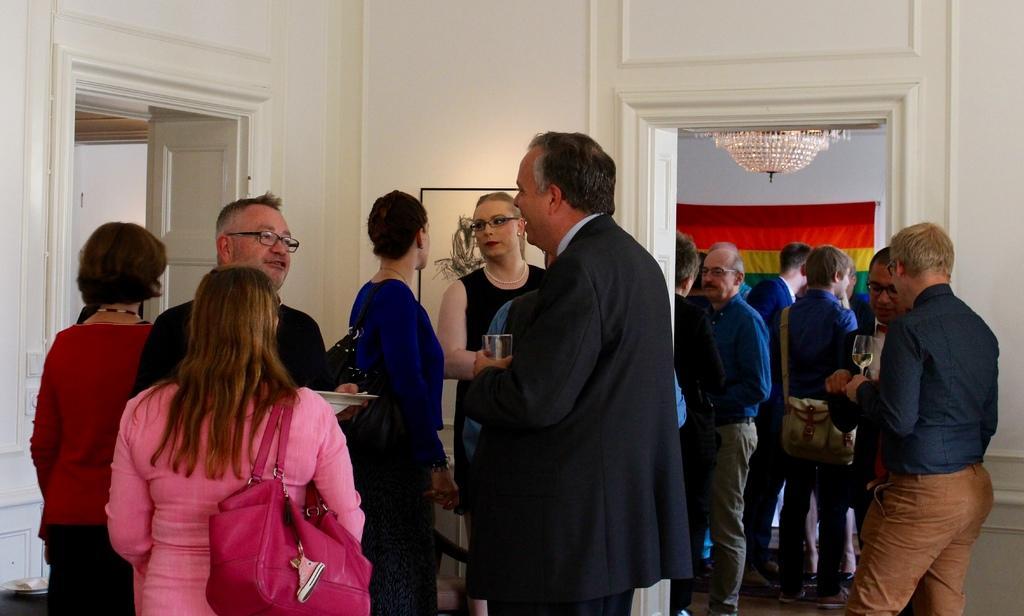In one or two sentences, can you explain what this image depicts? In the picture we can see group of people standing, some are holding glasses in their hands and in the background of the picture there is a wall to which photo frame is attached and we can see multi color cloth and there are some doors. 